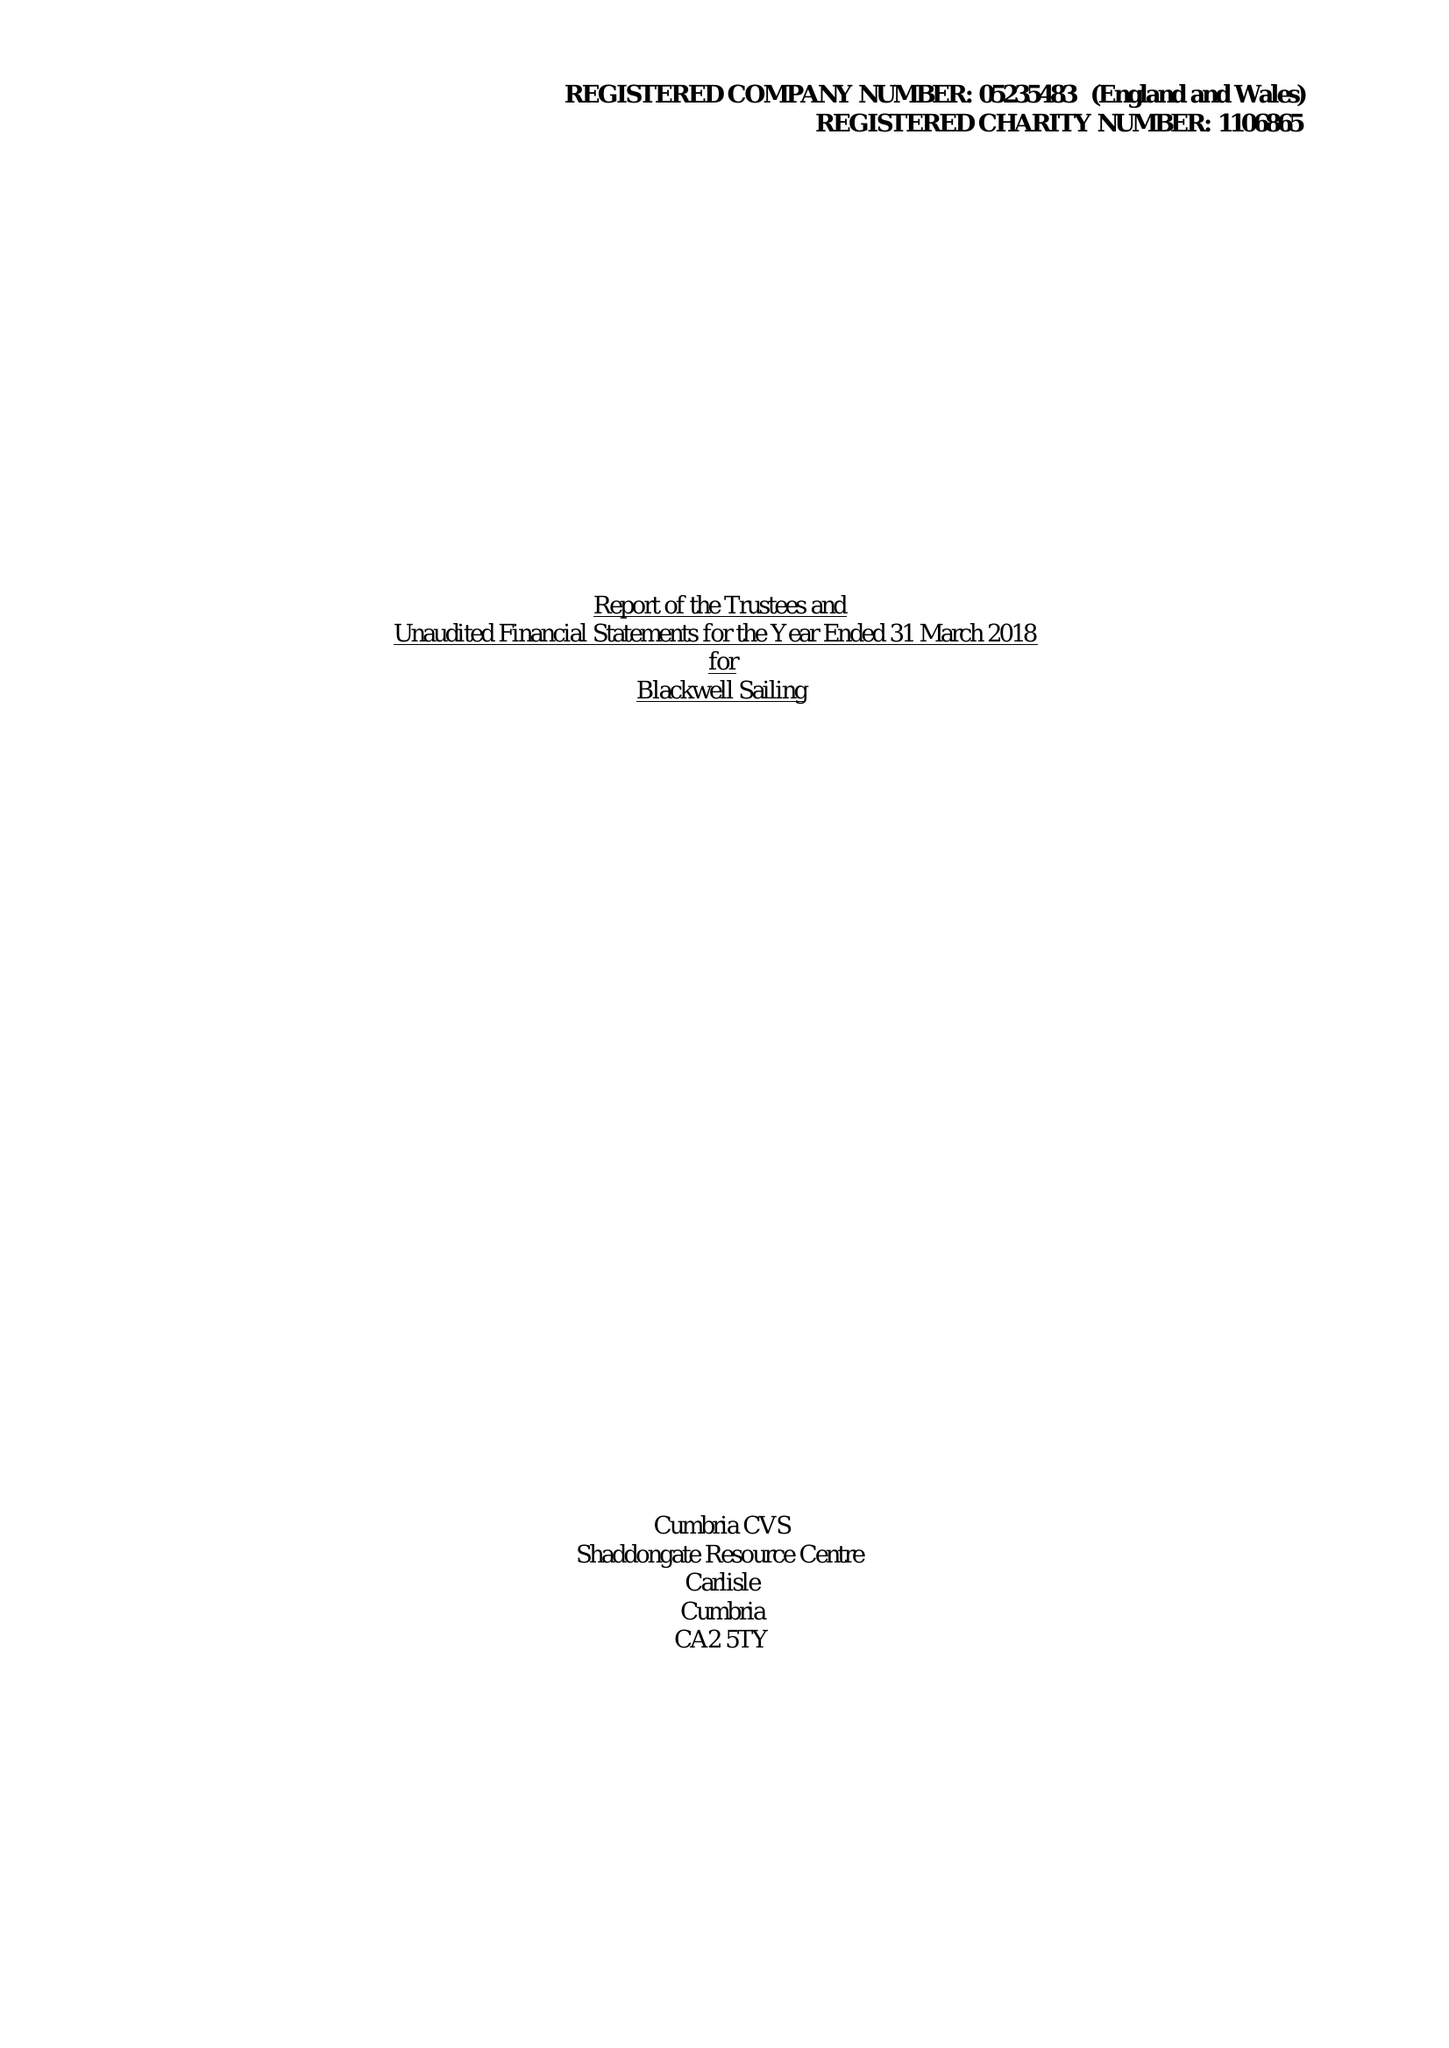What is the value for the charity_name?
Answer the question using a single word or phrase. Blackwell Sailing 